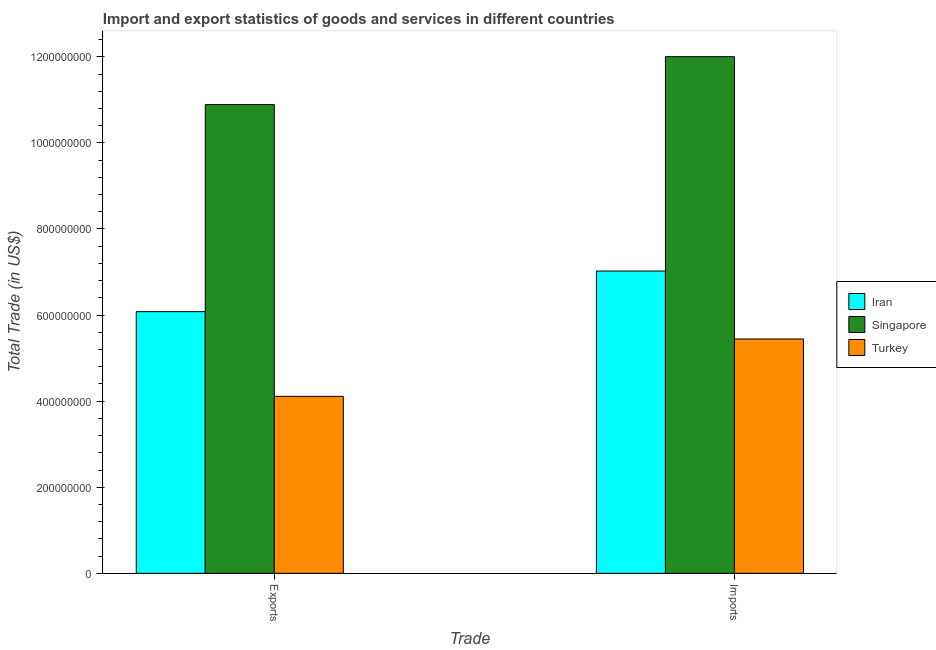How many different coloured bars are there?
Your answer should be very brief. 3. Are the number of bars per tick equal to the number of legend labels?
Your response must be concise. Yes. What is the label of the 2nd group of bars from the left?
Offer a very short reply. Imports. What is the imports of goods and services in Singapore?
Offer a very short reply. 1.20e+09. Across all countries, what is the maximum export of goods and services?
Make the answer very short. 1.09e+09. Across all countries, what is the minimum imports of goods and services?
Provide a short and direct response. 5.44e+08. In which country was the export of goods and services maximum?
Offer a very short reply. Singapore. What is the total export of goods and services in the graph?
Your answer should be compact. 2.11e+09. What is the difference between the export of goods and services in Turkey and that in Singapore?
Offer a very short reply. -6.78e+08. What is the difference between the export of goods and services in Turkey and the imports of goods and services in Iran?
Make the answer very short. -2.91e+08. What is the average export of goods and services per country?
Give a very brief answer. 7.03e+08. What is the difference between the imports of goods and services and export of goods and services in Turkey?
Keep it short and to the point. 1.33e+08. In how many countries, is the export of goods and services greater than 600000000 US$?
Your answer should be very brief. 2. What is the ratio of the imports of goods and services in Turkey to that in Singapore?
Keep it short and to the point. 0.45. Is the imports of goods and services in Singapore less than that in Iran?
Keep it short and to the point. No. What does the 2nd bar from the left in Exports represents?
Provide a succinct answer. Singapore. What does the 3rd bar from the right in Exports represents?
Keep it short and to the point. Iran. Does the graph contain any zero values?
Make the answer very short. No. Does the graph contain grids?
Provide a succinct answer. No. How many legend labels are there?
Your answer should be compact. 3. What is the title of the graph?
Your response must be concise. Import and export statistics of goods and services in different countries. Does "Qatar" appear as one of the legend labels in the graph?
Ensure brevity in your answer.  No. What is the label or title of the X-axis?
Your answer should be compact. Trade. What is the label or title of the Y-axis?
Provide a short and direct response. Total Trade (in US$). What is the Total Trade (in US$) in Iran in Exports?
Provide a short and direct response. 6.08e+08. What is the Total Trade (in US$) of Singapore in Exports?
Your response must be concise. 1.09e+09. What is the Total Trade (in US$) of Turkey in Exports?
Provide a short and direct response. 4.11e+08. What is the Total Trade (in US$) in Iran in Imports?
Give a very brief answer. 7.02e+08. What is the Total Trade (in US$) of Singapore in Imports?
Your answer should be very brief. 1.20e+09. What is the Total Trade (in US$) in Turkey in Imports?
Offer a terse response. 5.44e+08. Across all Trade, what is the maximum Total Trade (in US$) of Iran?
Keep it short and to the point. 7.02e+08. Across all Trade, what is the maximum Total Trade (in US$) in Singapore?
Give a very brief answer. 1.20e+09. Across all Trade, what is the maximum Total Trade (in US$) in Turkey?
Give a very brief answer. 5.44e+08. Across all Trade, what is the minimum Total Trade (in US$) in Iran?
Give a very brief answer. 6.08e+08. Across all Trade, what is the minimum Total Trade (in US$) of Singapore?
Provide a succinct answer. 1.09e+09. Across all Trade, what is the minimum Total Trade (in US$) in Turkey?
Your answer should be very brief. 4.11e+08. What is the total Total Trade (in US$) of Iran in the graph?
Ensure brevity in your answer.  1.31e+09. What is the total Total Trade (in US$) in Singapore in the graph?
Make the answer very short. 2.29e+09. What is the total Total Trade (in US$) of Turkey in the graph?
Offer a very short reply. 9.56e+08. What is the difference between the Total Trade (in US$) in Iran in Exports and that in Imports?
Provide a succinct answer. -9.43e+07. What is the difference between the Total Trade (in US$) of Singapore in Exports and that in Imports?
Provide a succinct answer. -1.11e+08. What is the difference between the Total Trade (in US$) in Turkey in Exports and that in Imports?
Keep it short and to the point. -1.33e+08. What is the difference between the Total Trade (in US$) in Iran in Exports and the Total Trade (in US$) in Singapore in Imports?
Provide a short and direct response. -5.92e+08. What is the difference between the Total Trade (in US$) in Iran in Exports and the Total Trade (in US$) in Turkey in Imports?
Ensure brevity in your answer.  6.35e+07. What is the difference between the Total Trade (in US$) in Singapore in Exports and the Total Trade (in US$) in Turkey in Imports?
Ensure brevity in your answer.  5.45e+08. What is the average Total Trade (in US$) in Iran per Trade?
Give a very brief answer. 6.55e+08. What is the average Total Trade (in US$) of Singapore per Trade?
Your answer should be compact. 1.14e+09. What is the average Total Trade (in US$) in Turkey per Trade?
Offer a very short reply. 4.78e+08. What is the difference between the Total Trade (in US$) in Iran and Total Trade (in US$) in Singapore in Exports?
Offer a terse response. -4.81e+08. What is the difference between the Total Trade (in US$) in Iran and Total Trade (in US$) in Turkey in Exports?
Give a very brief answer. 1.97e+08. What is the difference between the Total Trade (in US$) in Singapore and Total Trade (in US$) in Turkey in Exports?
Make the answer very short. 6.78e+08. What is the difference between the Total Trade (in US$) of Iran and Total Trade (in US$) of Singapore in Imports?
Your answer should be very brief. -4.98e+08. What is the difference between the Total Trade (in US$) in Iran and Total Trade (in US$) in Turkey in Imports?
Provide a succinct answer. 1.58e+08. What is the difference between the Total Trade (in US$) of Singapore and Total Trade (in US$) of Turkey in Imports?
Offer a very short reply. 6.56e+08. What is the ratio of the Total Trade (in US$) in Iran in Exports to that in Imports?
Give a very brief answer. 0.87. What is the ratio of the Total Trade (in US$) in Singapore in Exports to that in Imports?
Your response must be concise. 0.91. What is the ratio of the Total Trade (in US$) of Turkey in Exports to that in Imports?
Give a very brief answer. 0.76. What is the difference between the highest and the second highest Total Trade (in US$) in Iran?
Your response must be concise. 9.43e+07. What is the difference between the highest and the second highest Total Trade (in US$) in Singapore?
Provide a succinct answer. 1.11e+08. What is the difference between the highest and the second highest Total Trade (in US$) of Turkey?
Keep it short and to the point. 1.33e+08. What is the difference between the highest and the lowest Total Trade (in US$) in Iran?
Provide a short and direct response. 9.43e+07. What is the difference between the highest and the lowest Total Trade (in US$) of Singapore?
Provide a succinct answer. 1.11e+08. What is the difference between the highest and the lowest Total Trade (in US$) in Turkey?
Give a very brief answer. 1.33e+08. 